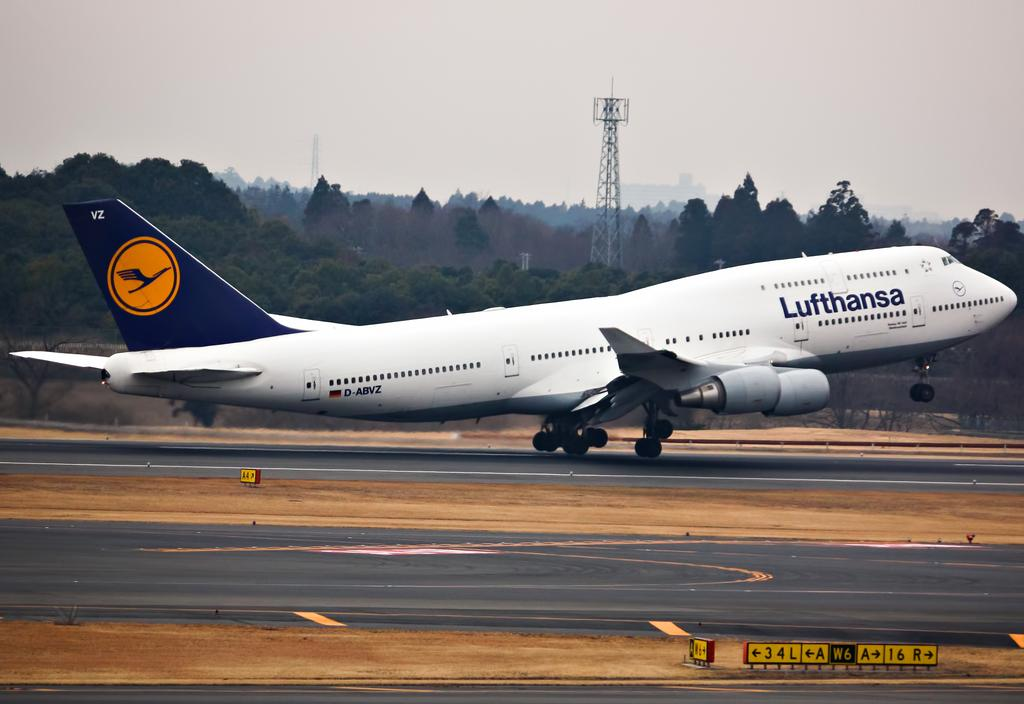What is the main subject in the center of the image? There is an aeroplane on the runway in the center of the image. What can be seen at the bottom of the image? There is a road at the bottom of the image. What is visible in the background of the image? There is a tower, trees, and the sky visible in the background of the image. Where is the ladybug carrying the bucket of jelly in the image? There is no ladybug or bucket of jelly present in the image. 